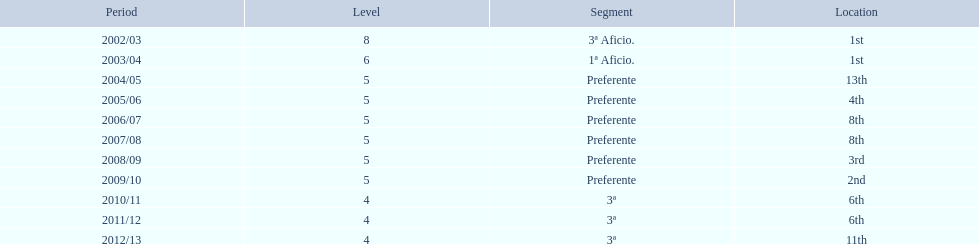How many times did  internacional de madrid cf come in 6th place? 6th, 6th. What is the first season that the team came in 6th place? 2010/11. Parse the full table. {'header': ['Period', 'Level', 'Segment', 'Location'], 'rows': [['2002/03', '8', '3ª Aficio.', '1st'], ['2003/04', '6', '1ª Aficio.', '1st'], ['2004/05', '5', 'Preferente', '13th'], ['2005/06', '5', 'Preferente', '4th'], ['2006/07', '5', 'Preferente', '8th'], ['2007/08', '5', 'Preferente', '8th'], ['2008/09', '5', 'Preferente', '3rd'], ['2009/10', '5', 'Preferente', '2nd'], ['2010/11', '4', '3ª', '6th'], ['2011/12', '4', '3ª', '6th'], ['2012/13', '4', '3ª', '11th']]} Which season after the first did they place in 6th again? 2011/12. 